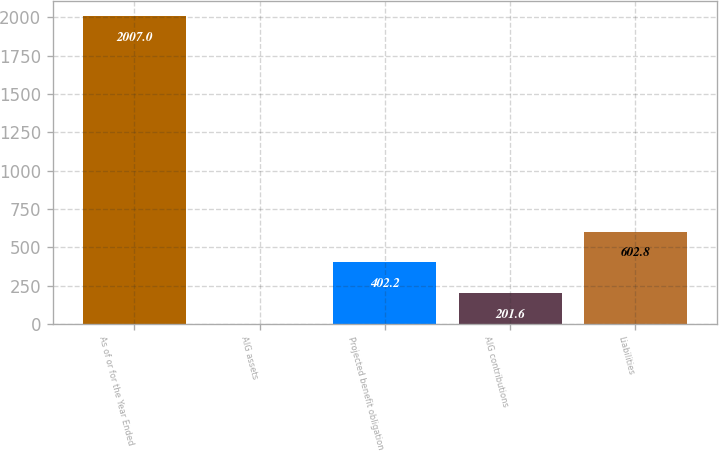Convert chart to OTSL. <chart><loc_0><loc_0><loc_500><loc_500><bar_chart><fcel>As of or for the Year Ended<fcel>AIG assets<fcel>Projected benefit obligation<fcel>AIG contributions<fcel>Liabilities<nl><fcel>2007<fcel>1<fcel>402.2<fcel>201.6<fcel>602.8<nl></chart> 